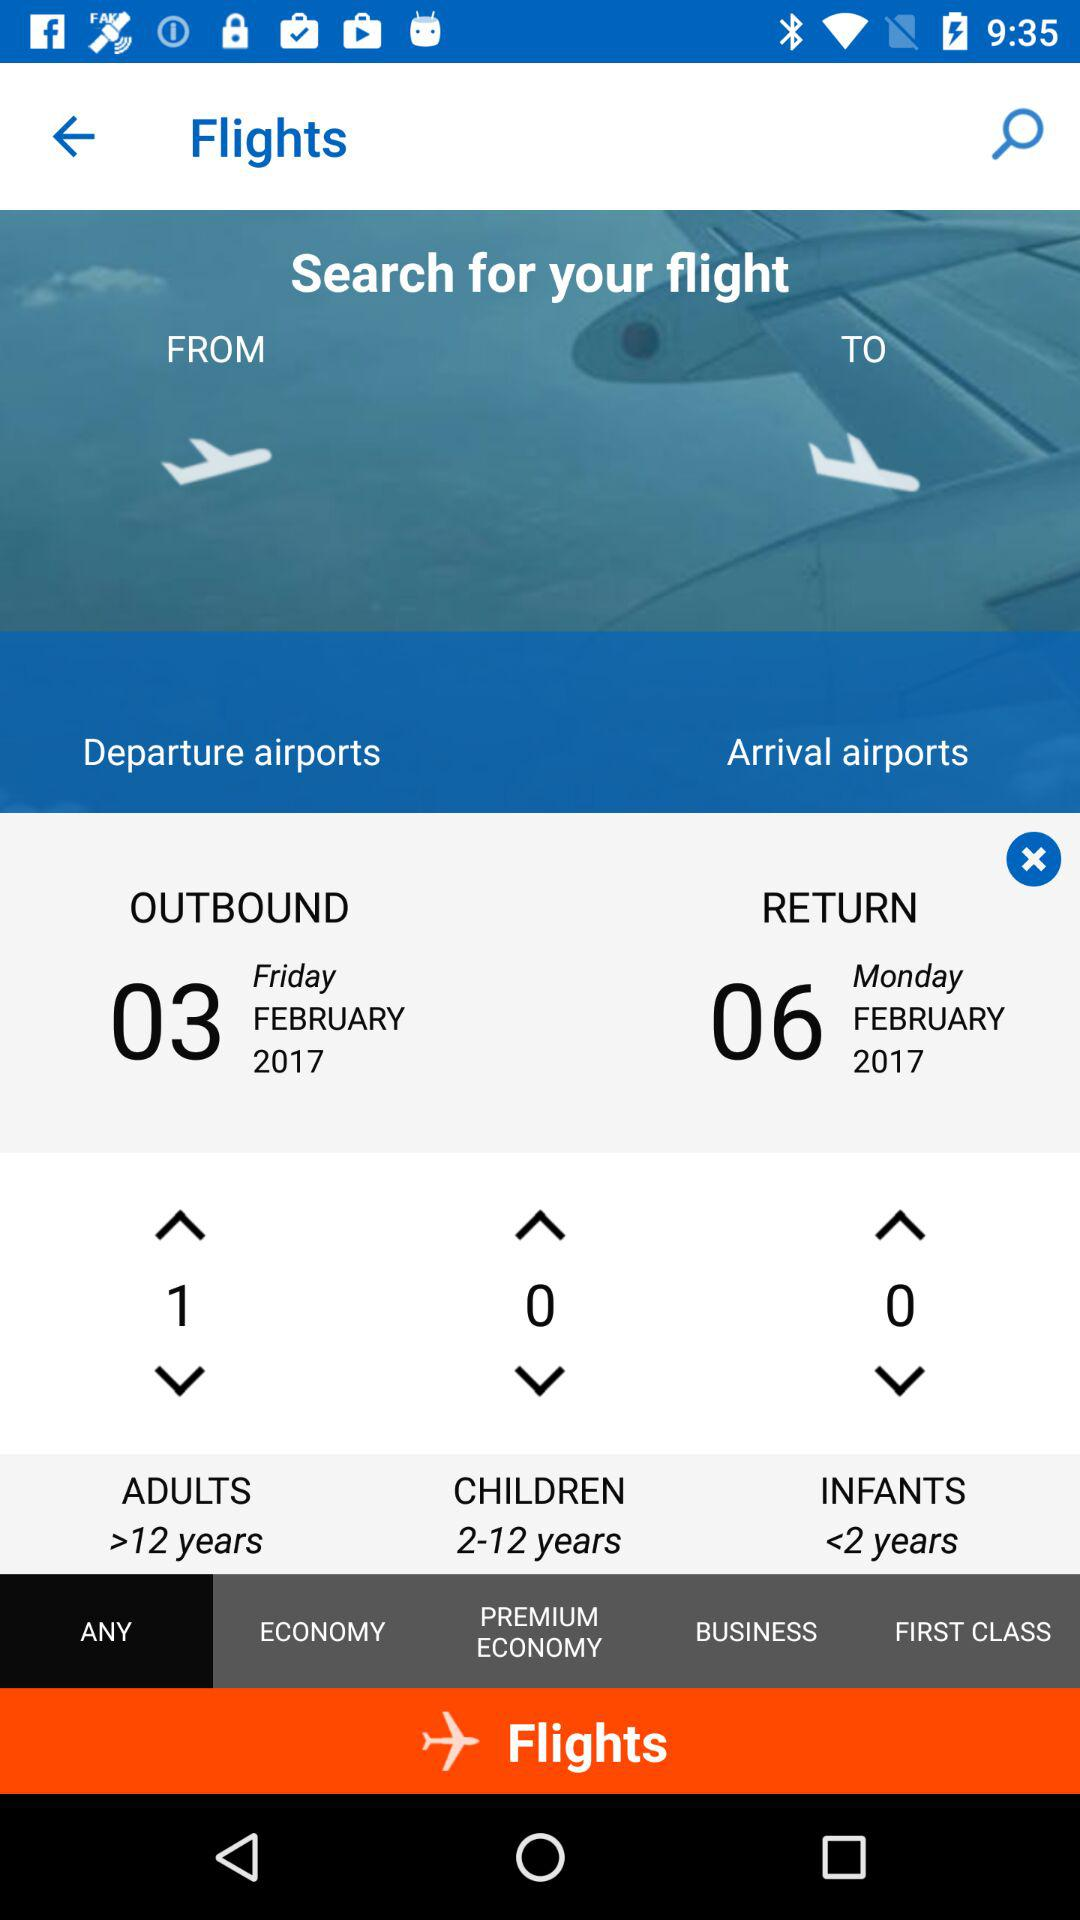Which tab has been selected? The tab that has been selected is "ANY". 